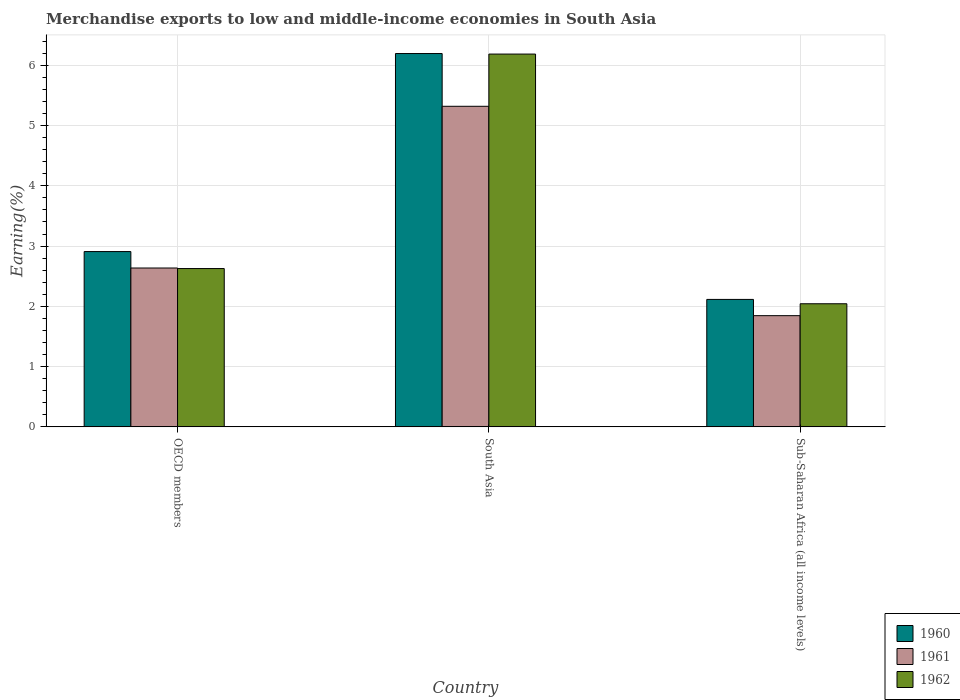Are the number of bars on each tick of the X-axis equal?
Provide a short and direct response. Yes. How many bars are there on the 3rd tick from the right?
Ensure brevity in your answer.  3. What is the label of the 2nd group of bars from the left?
Offer a terse response. South Asia. What is the percentage of amount earned from merchandise exports in 1960 in South Asia?
Your answer should be compact. 6.19. Across all countries, what is the maximum percentage of amount earned from merchandise exports in 1962?
Your response must be concise. 6.19. Across all countries, what is the minimum percentage of amount earned from merchandise exports in 1961?
Your answer should be very brief. 1.85. In which country was the percentage of amount earned from merchandise exports in 1962 maximum?
Your answer should be very brief. South Asia. In which country was the percentage of amount earned from merchandise exports in 1960 minimum?
Offer a terse response. Sub-Saharan Africa (all income levels). What is the total percentage of amount earned from merchandise exports in 1961 in the graph?
Your answer should be compact. 9.8. What is the difference between the percentage of amount earned from merchandise exports in 1961 in South Asia and that in Sub-Saharan Africa (all income levels)?
Make the answer very short. 3.47. What is the difference between the percentage of amount earned from merchandise exports in 1960 in Sub-Saharan Africa (all income levels) and the percentage of amount earned from merchandise exports in 1962 in OECD members?
Your response must be concise. -0.51. What is the average percentage of amount earned from merchandise exports in 1961 per country?
Provide a short and direct response. 3.27. What is the difference between the percentage of amount earned from merchandise exports of/in 1961 and percentage of amount earned from merchandise exports of/in 1962 in Sub-Saharan Africa (all income levels)?
Keep it short and to the point. -0.2. In how many countries, is the percentage of amount earned from merchandise exports in 1961 greater than 4.4 %?
Make the answer very short. 1. What is the ratio of the percentage of amount earned from merchandise exports in 1961 in OECD members to that in South Asia?
Your answer should be compact. 0.5. Is the percentage of amount earned from merchandise exports in 1962 in OECD members less than that in Sub-Saharan Africa (all income levels)?
Provide a short and direct response. No. What is the difference between the highest and the second highest percentage of amount earned from merchandise exports in 1961?
Provide a short and direct response. -0.79. What is the difference between the highest and the lowest percentage of amount earned from merchandise exports in 1960?
Provide a succinct answer. 4.08. In how many countries, is the percentage of amount earned from merchandise exports in 1961 greater than the average percentage of amount earned from merchandise exports in 1961 taken over all countries?
Offer a terse response. 1. What does the 2nd bar from the left in Sub-Saharan Africa (all income levels) represents?
Your response must be concise. 1961. How many bars are there?
Your answer should be compact. 9. Are all the bars in the graph horizontal?
Your answer should be compact. No. Are the values on the major ticks of Y-axis written in scientific E-notation?
Give a very brief answer. No. Does the graph contain any zero values?
Make the answer very short. No. Does the graph contain grids?
Your response must be concise. Yes. How are the legend labels stacked?
Make the answer very short. Vertical. What is the title of the graph?
Offer a very short reply. Merchandise exports to low and middle-income economies in South Asia. What is the label or title of the X-axis?
Give a very brief answer. Country. What is the label or title of the Y-axis?
Make the answer very short. Earning(%). What is the Earning(%) of 1960 in OECD members?
Give a very brief answer. 2.91. What is the Earning(%) of 1961 in OECD members?
Provide a short and direct response. 2.64. What is the Earning(%) in 1962 in OECD members?
Give a very brief answer. 2.63. What is the Earning(%) of 1960 in South Asia?
Make the answer very short. 6.19. What is the Earning(%) of 1961 in South Asia?
Provide a short and direct response. 5.32. What is the Earning(%) in 1962 in South Asia?
Provide a succinct answer. 6.19. What is the Earning(%) of 1960 in Sub-Saharan Africa (all income levels)?
Your response must be concise. 2.11. What is the Earning(%) in 1961 in Sub-Saharan Africa (all income levels)?
Ensure brevity in your answer.  1.85. What is the Earning(%) in 1962 in Sub-Saharan Africa (all income levels)?
Keep it short and to the point. 2.04. Across all countries, what is the maximum Earning(%) of 1960?
Provide a short and direct response. 6.19. Across all countries, what is the maximum Earning(%) in 1961?
Make the answer very short. 5.32. Across all countries, what is the maximum Earning(%) of 1962?
Provide a succinct answer. 6.19. Across all countries, what is the minimum Earning(%) of 1960?
Provide a short and direct response. 2.11. Across all countries, what is the minimum Earning(%) of 1961?
Ensure brevity in your answer.  1.85. Across all countries, what is the minimum Earning(%) in 1962?
Offer a terse response. 2.04. What is the total Earning(%) in 1960 in the graph?
Your answer should be compact. 11.22. What is the total Earning(%) of 1962 in the graph?
Provide a succinct answer. 10.86. What is the difference between the Earning(%) of 1960 in OECD members and that in South Asia?
Give a very brief answer. -3.29. What is the difference between the Earning(%) in 1961 in OECD members and that in South Asia?
Give a very brief answer. -2.68. What is the difference between the Earning(%) of 1962 in OECD members and that in South Asia?
Offer a very short reply. -3.56. What is the difference between the Earning(%) in 1960 in OECD members and that in Sub-Saharan Africa (all income levels)?
Offer a terse response. 0.79. What is the difference between the Earning(%) in 1961 in OECD members and that in Sub-Saharan Africa (all income levels)?
Give a very brief answer. 0.79. What is the difference between the Earning(%) in 1962 in OECD members and that in Sub-Saharan Africa (all income levels)?
Give a very brief answer. 0.58. What is the difference between the Earning(%) of 1960 in South Asia and that in Sub-Saharan Africa (all income levels)?
Your answer should be very brief. 4.08. What is the difference between the Earning(%) of 1961 in South Asia and that in Sub-Saharan Africa (all income levels)?
Offer a terse response. 3.47. What is the difference between the Earning(%) of 1962 in South Asia and that in Sub-Saharan Africa (all income levels)?
Give a very brief answer. 4.14. What is the difference between the Earning(%) of 1960 in OECD members and the Earning(%) of 1961 in South Asia?
Offer a terse response. -2.41. What is the difference between the Earning(%) in 1960 in OECD members and the Earning(%) in 1962 in South Asia?
Provide a succinct answer. -3.28. What is the difference between the Earning(%) in 1961 in OECD members and the Earning(%) in 1962 in South Asia?
Your answer should be compact. -3.55. What is the difference between the Earning(%) in 1960 in OECD members and the Earning(%) in 1961 in Sub-Saharan Africa (all income levels)?
Offer a terse response. 1.06. What is the difference between the Earning(%) of 1960 in OECD members and the Earning(%) of 1962 in Sub-Saharan Africa (all income levels)?
Keep it short and to the point. 0.87. What is the difference between the Earning(%) of 1961 in OECD members and the Earning(%) of 1962 in Sub-Saharan Africa (all income levels)?
Offer a very short reply. 0.59. What is the difference between the Earning(%) of 1960 in South Asia and the Earning(%) of 1961 in Sub-Saharan Africa (all income levels)?
Keep it short and to the point. 4.35. What is the difference between the Earning(%) of 1960 in South Asia and the Earning(%) of 1962 in Sub-Saharan Africa (all income levels)?
Keep it short and to the point. 4.15. What is the difference between the Earning(%) in 1961 in South Asia and the Earning(%) in 1962 in Sub-Saharan Africa (all income levels)?
Your answer should be very brief. 3.28. What is the average Earning(%) in 1960 per country?
Your answer should be very brief. 3.74. What is the average Earning(%) of 1961 per country?
Provide a short and direct response. 3.27. What is the average Earning(%) in 1962 per country?
Make the answer very short. 3.62. What is the difference between the Earning(%) of 1960 and Earning(%) of 1961 in OECD members?
Make the answer very short. 0.27. What is the difference between the Earning(%) in 1960 and Earning(%) in 1962 in OECD members?
Your answer should be very brief. 0.28. What is the difference between the Earning(%) in 1961 and Earning(%) in 1962 in OECD members?
Provide a succinct answer. 0.01. What is the difference between the Earning(%) in 1960 and Earning(%) in 1961 in South Asia?
Provide a succinct answer. 0.88. What is the difference between the Earning(%) in 1960 and Earning(%) in 1962 in South Asia?
Your response must be concise. 0.01. What is the difference between the Earning(%) of 1961 and Earning(%) of 1962 in South Asia?
Offer a terse response. -0.87. What is the difference between the Earning(%) of 1960 and Earning(%) of 1961 in Sub-Saharan Africa (all income levels)?
Offer a terse response. 0.27. What is the difference between the Earning(%) in 1960 and Earning(%) in 1962 in Sub-Saharan Africa (all income levels)?
Give a very brief answer. 0.07. What is the difference between the Earning(%) in 1961 and Earning(%) in 1962 in Sub-Saharan Africa (all income levels)?
Your response must be concise. -0.2. What is the ratio of the Earning(%) in 1960 in OECD members to that in South Asia?
Offer a terse response. 0.47. What is the ratio of the Earning(%) of 1961 in OECD members to that in South Asia?
Ensure brevity in your answer.  0.5. What is the ratio of the Earning(%) of 1962 in OECD members to that in South Asia?
Give a very brief answer. 0.42. What is the ratio of the Earning(%) in 1960 in OECD members to that in Sub-Saharan Africa (all income levels)?
Keep it short and to the point. 1.38. What is the ratio of the Earning(%) in 1961 in OECD members to that in Sub-Saharan Africa (all income levels)?
Your answer should be compact. 1.43. What is the ratio of the Earning(%) in 1962 in OECD members to that in Sub-Saharan Africa (all income levels)?
Your answer should be compact. 1.29. What is the ratio of the Earning(%) of 1960 in South Asia to that in Sub-Saharan Africa (all income levels)?
Offer a terse response. 2.93. What is the ratio of the Earning(%) of 1961 in South Asia to that in Sub-Saharan Africa (all income levels)?
Offer a very short reply. 2.88. What is the ratio of the Earning(%) of 1962 in South Asia to that in Sub-Saharan Africa (all income levels)?
Make the answer very short. 3.03. What is the difference between the highest and the second highest Earning(%) of 1960?
Provide a short and direct response. 3.29. What is the difference between the highest and the second highest Earning(%) in 1961?
Give a very brief answer. 2.68. What is the difference between the highest and the second highest Earning(%) in 1962?
Ensure brevity in your answer.  3.56. What is the difference between the highest and the lowest Earning(%) in 1960?
Provide a succinct answer. 4.08. What is the difference between the highest and the lowest Earning(%) of 1961?
Provide a succinct answer. 3.47. What is the difference between the highest and the lowest Earning(%) in 1962?
Make the answer very short. 4.14. 